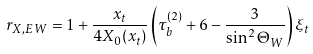Convert formula to latex. <formula><loc_0><loc_0><loc_500><loc_500>r _ { X , E W } = 1 + \frac { x _ { t } } { 4 X _ { 0 } ( x _ { t } ) } \left ( \tau _ { b } ^ { ( 2 ) } + 6 - \frac { 3 } { \sin ^ { 2 } \Theta _ { W } } \right ) \xi _ { t }</formula> 